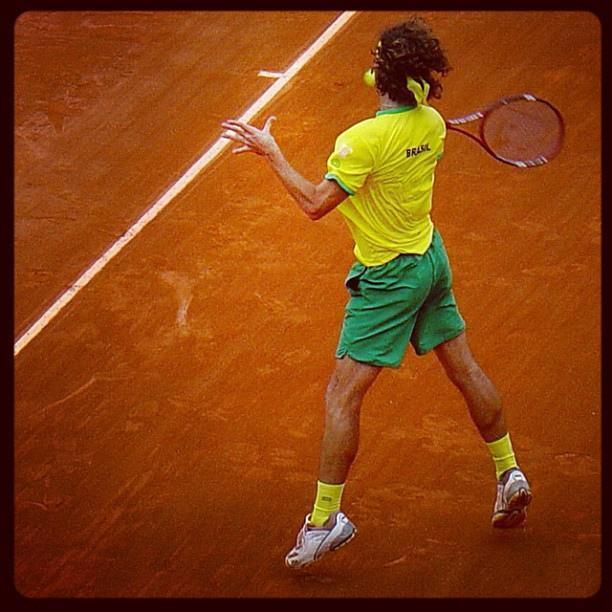What is this man doing?
Choose the correct response, then elucidate: 'Answer: answer
Rationale: rationale.'
Options: Return ball, quit, loving, serving. Answer: return ball.
Rationale: The man is getting ready to hit the ball back. 